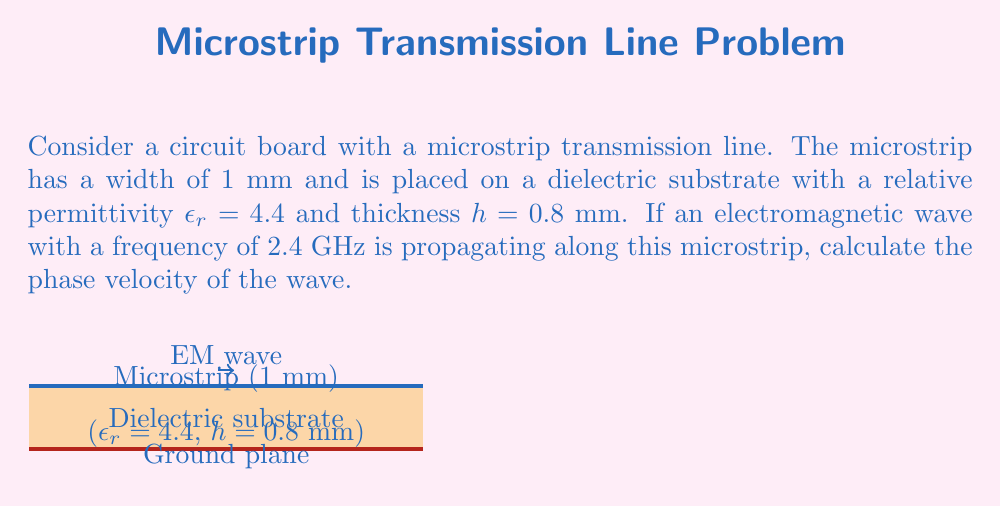Give your solution to this math problem. To solve this problem, we'll follow these steps:

1) First, we need to calculate the effective dielectric constant ($\epsilon_{eff}$) of the microstrip line. For a microstrip, $\epsilon_{eff}$ is always between 1 (air) and $\epsilon_r$ (substrate). We can use the following approximation:

   $$\epsilon_{eff} = \frac{\epsilon_r + 1}{2} + \frac{\epsilon_r - 1}{2}\left(1 + 12\frac{h}{w}\right)^{-1/2}$$

   where $w$ is the width of the microstrip and $h$ is the thickness of the substrate.

2) Substituting the given values:
   
   $$\epsilon_{eff} = \frac{4.4 + 1}{2} + \frac{4.4 - 1}{2}\left(1 + 12\frac{0.8}{1}\right)^{-1/2}$$

3) Calculating:
   
   $$\epsilon_{eff} = 2.7 + 1.7(1 + 9.6)^{-1/2} \approx 3.3$$

4) Now, we can calculate the phase velocity. The phase velocity in a medium is given by:

   $$v_p = \frac{c}{\sqrt{\epsilon_{eff}}}$$

   where $c$ is the speed of light in vacuum ($3 \times 10^8$ m/s).

5) Substituting the values:

   $$v_p = \frac{3 \times 10^8}{\sqrt{3.3}} \approx 1.65 \times 10^8 \text{ m/s}$$

Thus, the phase velocity of the electromagnetic wave on this microstrip is approximately $1.65 \times 10^8$ m/s.
Answer: $1.65 \times 10^8$ m/s 